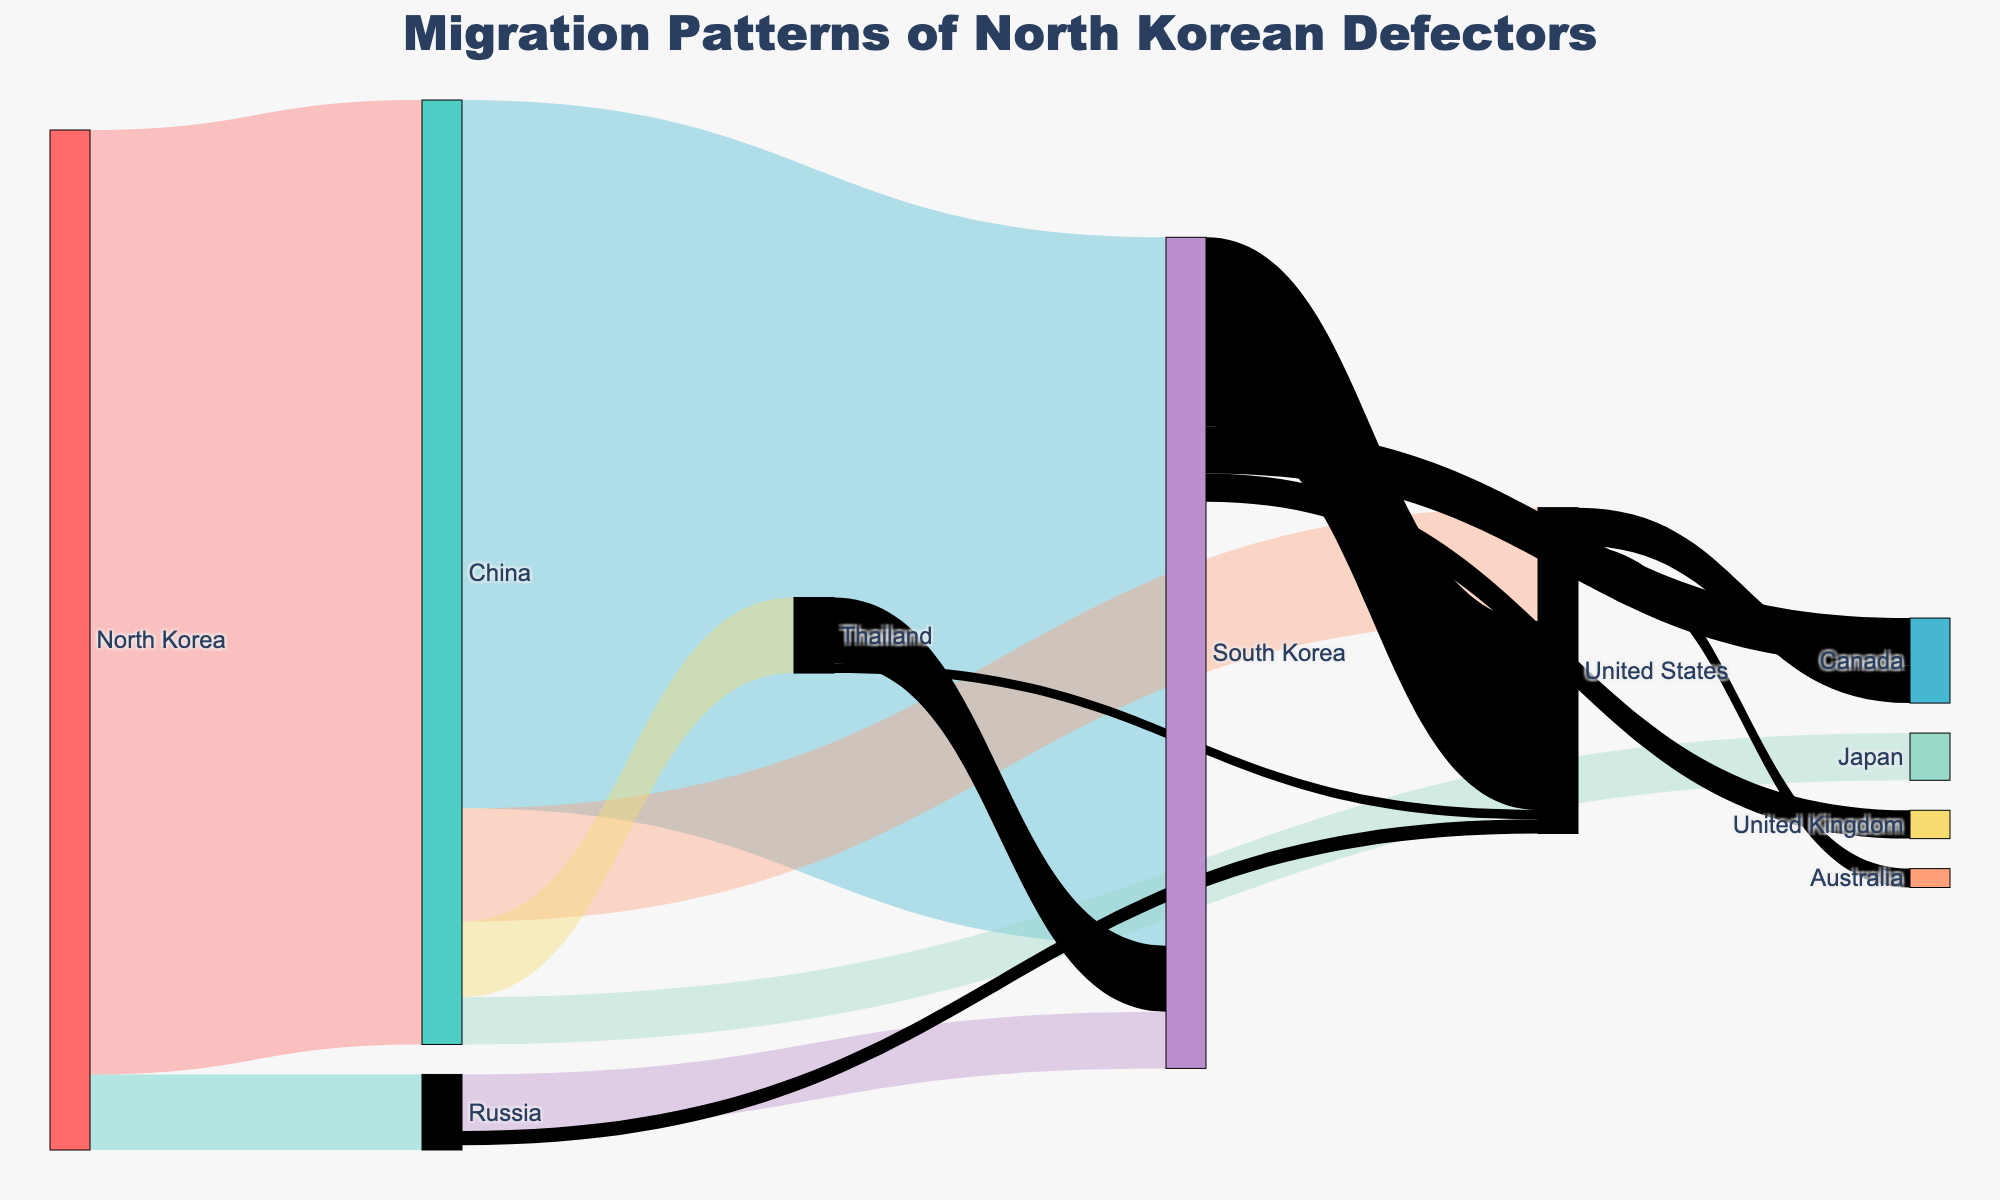What is the title of the Sankey Diagram? The title is usually prominently displayed at the top of the diagram. In this case, the title is clearly written in a larger font size for easy readability.
Answer: Migration Patterns of North Korean Defectors Which country receives the highest number of defectors from North Korea? By observing the width of the flows originating from North Korea, the flow to China appears to be the widest, indicating the highest value. The data also confirms this.
Answer: China How many defectors move from China to South Korea? In the Sankey Diagram, follow the flow from China to South Korea and read the value associated with it. The width of the flow reflects 7,500 defectors.
Answer: 7,500 How many countries do defectors migrate to from South Korea? To answer this, count the number of flows originating from South Korea. The diagram shows three flows going to the United States, Canada, and the United Kingdom.
Answer: 3 Which country has fewer defectors arriving from Russia: South Korea or the United States? Compare the flows from Russia to South Korea and the United States. The flow to South Korea is wider (600 defectors) compared to the flow to the United States (150 defectors).
Answer: United States How many defectors migrated from North Korea to Thailand through China? Sum the values of the flows from North Korea to China and then from China to Thailand. The data shows 10,000 defectors from North Korea to China, and then 800 from China to Thailand. However, since the journey's indirect, only the latter flow is needed.
Answer: 800 What is the total number of North Korean defectors who end up in the United States, considering all paths? Identify and sum all flows terminating in the United States: from China (1,200), from Russia (150), from Thailand (100), from South Korea (2,000). This gives a total of 1,200 + 150 + 100 + 2,000.
Answer: 3,450 How many defectors move internationally (to another country) from China? Sum the values of the flows from China to different countries: South Korea (7,500), United States (1,200), Japan (500), and Thailand (800). The total is 7,500 + 1,200 + 500 + 800.
Answer: 10,000 Which country serves as an intermediate stop for the largest number of defectors coming from North Korea? Determine which country has the largest sum of incoming defectors from North Korea before they move on to other destinations. China receives the most defectors from North Korea with a total of 10,000.
Answer: China 